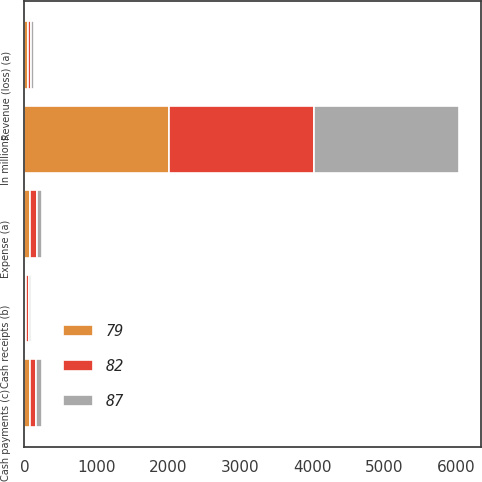<chart> <loc_0><loc_0><loc_500><loc_500><stacked_bar_chart><ecel><fcel>In millions<fcel>Revenue (loss) (a)<fcel>Expense (a)<fcel>Cash receipts (b)<fcel>Cash payments (c)<nl><fcel>82<fcel>2012<fcel>49<fcel>90<fcel>36<fcel>87<nl><fcel>79<fcel>2011<fcel>49<fcel>79<fcel>28<fcel>79<nl><fcel>87<fcel>2010<fcel>42<fcel>79<fcel>32<fcel>82<nl></chart> 